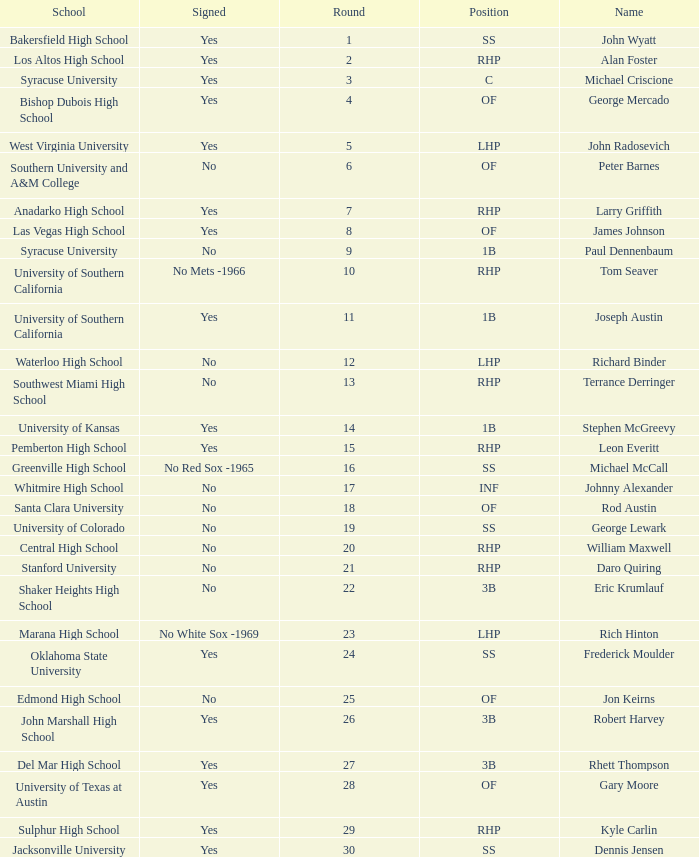What is the name of the player taken in round 23? Rich Hinton. 